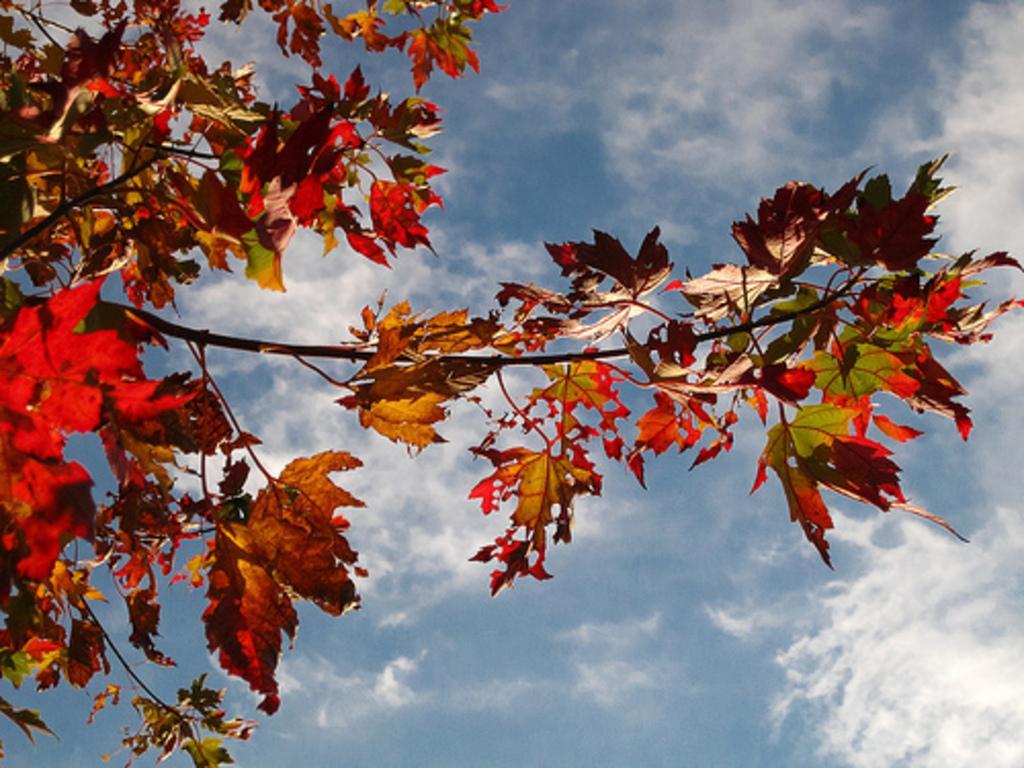Can you describe this image briefly? In the image there are branches with leaves. Behind them there is sky with clouds. 